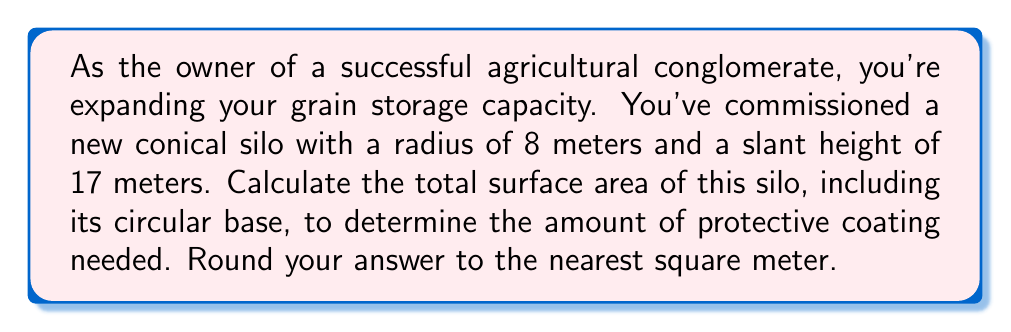Give your solution to this math problem. Let's approach this step-by-step:

1) The surface area of a cone consists of two parts:
   a) The lateral surface area (the curved surface)
   b) The area of the circular base

2) For the lateral surface area, we use the formula:
   $$A_{\text{lateral}} = \pi r s$$
   where $r$ is the radius of the base and $s$ is the slant height.

3) Given: 
   Radius ($r$) = 8 meters
   Slant height ($s$) = 17 meters

4) Calculating the lateral surface area:
   $$A_{\text{lateral}} = \pi (8)(17) = 136\pi \text{ m}^2$$

5) For the circular base, we use the formula:
   $$A_{\text{base}} = \pi r^2$$

6) Calculating the base area:
   $$A_{\text{base}} = \pi (8)^2 = 64\pi \text{ m}^2$$

7) The total surface area is the sum of the lateral area and the base area:
   $$A_{\text{total}} = A_{\text{lateral}} + A_{\text{base}}$$
   $$A_{\text{total}} = 136\pi + 64\pi = 200\pi \text{ m}^2$$

8) Converting to a numerical value:
   $$A_{\text{total}} = 200 \times 3.14159... \approx 628.32 \text{ m}^2$$

9) Rounding to the nearest square meter:
   $$A_{\text{total}} \approx 628 \text{ m}^2$$

[asy]
import geometry;

size(200);

pair O=(0,0);
pair A=(5,0);
pair B=(-5,0);
pair C=(0,10);

draw(A--C--B--cycle);
draw(Circle(O,5));

label("8m",O--A,S);
label("17m",O--C,NE);

[/asy]
Answer: The total surface area of the conical silo is approximately 628 square meters. 